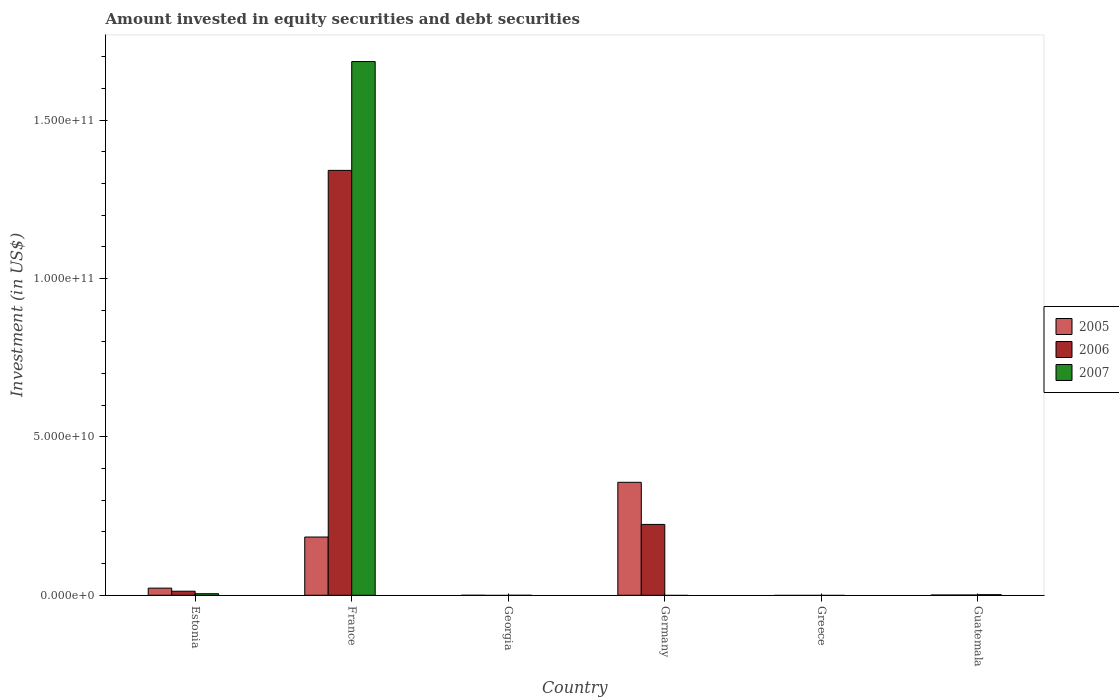How many different coloured bars are there?
Offer a terse response. 3. How many bars are there on the 5th tick from the left?
Provide a succinct answer. 0. What is the label of the 1st group of bars from the left?
Ensure brevity in your answer.  Estonia. What is the amount invested in equity securities and debt securities in 2007 in Estonia?
Give a very brief answer. 4.95e+08. Across all countries, what is the maximum amount invested in equity securities and debt securities in 2006?
Offer a terse response. 1.34e+11. What is the total amount invested in equity securities and debt securities in 2007 in the graph?
Your response must be concise. 1.69e+11. What is the difference between the amount invested in equity securities and debt securities in 2005 in France and that in Germany?
Give a very brief answer. -1.73e+1. What is the difference between the amount invested in equity securities and debt securities in 2007 in Greece and the amount invested in equity securities and debt securities in 2006 in Estonia?
Your response must be concise. -1.28e+09. What is the average amount invested in equity securities and debt securities in 2007 per country?
Give a very brief answer. 2.82e+1. What is the difference between the amount invested in equity securities and debt securities of/in 2006 and amount invested in equity securities and debt securities of/in 2007 in Guatemala?
Offer a very short reply. -1.02e+08. In how many countries, is the amount invested in equity securities and debt securities in 2005 greater than 120000000000 US$?
Make the answer very short. 0. What is the ratio of the amount invested in equity securities and debt securities in 2005 in France to that in Guatemala?
Your answer should be compact. 239.47. Is the amount invested in equity securities and debt securities in 2005 in France less than that in Guatemala?
Keep it short and to the point. No. What is the difference between the highest and the second highest amount invested in equity securities and debt securities in 2005?
Offer a terse response. 3.34e+1. What is the difference between the highest and the lowest amount invested in equity securities and debt securities in 2006?
Your answer should be very brief. 1.34e+11. In how many countries, is the amount invested in equity securities and debt securities in 2006 greater than the average amount invested in equity securities and debt securities in 2006 taken over all countries?
Your answer should be compact. 1. How many bars are there?
Provide a succinct answer. 11. Are all the bars in the graph horizontal?
Offer a terse response. No. How many countries are there in the graph?
Provide a succinct answer. 6. What is the difference between two consecutive major ticks on the Y-axis?
Provide a succinct answer. 5.00e+1. Does the graph contain any zero values?
Provide a short and direct response. Yes. Where does the legend appear in the graph?
Keep it short and to the point. Center right. How are the legend labels stacked?
Ensure brevity in your answer.  Vertical. What is the title of the graph?
Give a very brief answer. Amount invested in equity securities and debt securities. What is the label or title of the X-axis?
Provide a short and direct response. Country. What is the label or title of the Y-axis?
Your response must be concise. Investment (in US$). What is the Investment (in US$) of 2005 in Estonia?
Keep it short and to the point. 2.25e+09. What is the Investment (in US$) of 2006 in Estonia?
Make the answer very short. 1.28e+09. What is the Investment (in US$) in 2007 in Estonia?
Make the answer very short. 4.95e+08. What is the Investment (in US$) of 2005 in France?
Give a very brief answer. 1.84e+1. What is the Investment (in US$) in 2006 in France?
Provide a short and direct response. 1.34e+11. What is the Investment (in US$) of 2007 in France?
Offer a terse response. 1.69e+11. What is the Investment (in US$) of 2005 in Georgia?
Keep it short and to the point. 0. What is the Investment (in US$) of 2006 in Georgia?
Ensure brevity in your answer.  0. What is the Investment (in US$) of 2005 in Germany?
Give a very brief answer. 3.57e+1. What is the Investment (in US$) of 2006 in Germany?
Offer a terse response. 2.24e+1. What is the Investment (in US$) of 2006 in Greece?
Keep it short and to the point. 0. What is the Investment (in US$) in 2007 in Greece?
Your answer should be compact. 0. What is the Investment (in US$) of 2005 in Guatemala?
Your response must be concise. 7.68e+07. What is the Investment (in US$) in 2006 in Guatemala?
Ensure brevity in your answer.  8.34e+07. What is the Investment (in US$) in 2007 in Guatemala?
Your answer should be very brief. 1.85e+08. Across all countries, what is the maximum Investment (in US$) in 2005?
Your answer should be compact. 3.57e+1. Across all countries, what is the maximum Investment (in US$) in 2006?
Provide a short and direct response. 1.34e+11. Across all countries, what is the maximum Investment (in US$) in 2007?
Offer a terse response. 1.69e+11. Across all countries, what is the minimum Investment (in US$) in 2005?
Keep it short and to the point. 0. Across all countries, what is the minimum Investment (in US$) in 2006?
Ensure brevity in your answer.  0. Across all countries, what is the minimum Investment (in US$) of 2007?
Your response must be concise. 0. What is the total Investment (in US$) in 2005 in the graph?
Make the answer very short. 5.64e+1. What is the total Investment (in US$) in 2006 in the graph?
Offer a terse response. 1.58e+11. What is the total Investment (in US$) in 2007 in the graph?
Your answer should be very brief. 1.69e+11. What is the difference between the Investment (in US$) of 2005 in Estonia and that in France?
Ensure brevity in your answer.  -1.61e+1. What is the difference between the Investment (in US$) of 2006 in Estonia and that in France?
Provide a short and direct response. -1.33e+11. What is the difference between the Investment (in US$) in 2007 in Estonia and that in France?
Offer a very short reply. -1.68e+11. What is the difference between the Investment (in US$) of 2005 in Estonia and that in Germany?
Your answer should be very brief. -3.34e+1. What is the difference between the Investment (in US$) of 2006 in Estonia and that in Germany?
Keep it short and to the point. -2.11e+1. What is the difference between the Investment (in US$) of 2005 in Estonia and that in Guatemala?
Your answer should be compact. 2.18e+09. What is the difference between the Investment (in US$) of 2006 in Estonia and that in Guatemala?
Your answer should be very brief. 1.20e+09. What is the difference between the Investment (in US$) of 2007 in Estonia and that in Guatemala?
Your response must be concise. 3.10e+08. What is the difference between the Investment (in US$) of 2005 in France and that in Germany?
Your answer should be compact. -1.73e+1. What is the difference between the Investment (in US$) of 2006 in France and that in Germany?
Keep it short and to the point. 1.12e+11. What is the difference between the Investment (in US$) of 2005 in France and that in Guatemala?
Offer a terse response. 1.83e+1. What is the difference between the Investment (in US$) in 2006 in France and that in Guatemala?
Give a very brief answer. 1.34e+11. What is the difference between the Investment (in US$) in 2007 in France and that in Guatemala?
Keep it short and to the point. 1.68e+11. What is the difference between the Investment (in US$) in 2005 in Germany and that in Guatemala?
Give a very brief answer. 3.56e+1. What is the difference between the Investment (in US$) of 2006 in Germany and that in Guatemala?
Make the answer very short. 2.23e+1. What is the difference between the Investment (in US$) of 2005 in Estonia and the Investment (in US$) of 2006 in France?
Ensure brevity in your answer.  -1.32e+11. What is the difference between the Investment (in US$) of 2005 in Estonia and the Investment (in US$) of 2007 in France?
Offer a very short reply. -1.66e+11. What is the difference between the Investment (in US$) of 2006 in Estonia and the Investment (in US$) of 2007 in France?
Your answer should be compact. -1.67e+11. What is the difference between the Investment (in US$) in 2005 in Estonia and the Investment (in US$) in 2006 in Germany?
Provide a short and direct response. -2.01e+1. What is the difference between the Investment (in US$) in 2005 in Estonia and the Investment (in US$) in 2006 in Guatemala?
Offer a very short reply. 2.17e+09. What is the difference between the Investment (in US$) in 2005 in Estonia and the Investment (in US$) in 2007 in Guatemala?
Your answer should be compact. 2.07e+09. What is the difference between the Investment (in US$) of 2006 in Estonia and the Investment (in US$) of 2007 in Guatemala?
Offer a terse response. 1.10e+09. What is the difference between the Investment (in US$) in 2005 in France and the Investment (in US$) in 2006 in Germany?
Offer a terse response. -3.98e+09. What is the difference between the Investment (in US$) in 2005 in France and the Investment (in US$) in 2006 in Guatemala?
Offer a very short reply. 1.83e+1. What is the difference between the Investment (in US$) of 2005 in France and the Investment (in US$) of 2007 in Guatemala?
Ensure brevity in your answer.  1.82e+1. What is the difference between the Investment (in US$) of 2006 in France and the Investment (in US$) of 2007 in Guatemala?
Keep it short and to the point. 1.34e+11. What is the difference between the Investment (in US$) of 2005 in Germany and the Investment (in US$) of 2006 in Guatemala?
Your answer should be compact. 3.56e+1. What is the difference between the Investment (in US$) in 2005 in Germany and the Investment (in US$) in 2007 in Guatemala?
Provide a short and direct response. 3.55e+1. What is the difference between the Investment (in US$) of 2006 in Germany and the Investment (in US$) of 2007 in Guatemala?
Provide a succinct answer. 2.22e+1. What is the average Investment (in US$) in 2005 per country?
Offer a terse response. 9.40e+09. What is the average Investment (in US$) in 2006 per country?
Give a very brief answer. 2.63e+1. What is the average Investment (in US$) in 2007 per country?
Your answer should be very brief. 2.82e+1. What is the difference between the Investment (in US$) of 2005 and Investment (in US$) of 2006 in Estonia?
Offer a terse response. 9.71e+08. What is the difference between the Investment (in US$) in 2005 and Investment (in US$) in 2007 in Estonia?
Offer a very short reply. 1.76e+09. What is the difference between the Investment (in US$) of 2006 and Investment (in US$) of 2007 in Estonia?
Your answer should be very brief. 7.89e+08. What is the difference between the Investment (in US$) of 2005 and Investment (in US$) of 2006 in France?
Give a very brief answer. -1.16e+11. What is the difference between the Investment (in US$) of 2005 and Investment (in US$) of 2007 in France?
Provide a short and direct response. -1.50e+11. What is the difference between the Investment (in US$) in 2006 and Investment (in US$) in 2007 in France?
Make the answer very short. -3.44e+1. What is the difference between the Investment (in US$) of 2005 and Investment (in US$) of 2006 in Germany?
Offer a very short reply. 1.33e+1. What is the difference between the Investment (in US$) of 2005 and Investment (in US$) of 2006 in Guatemala?
Your answer should be very brief. -6.60e+06. What is the difference between the Investment (in US$) in 2005 and Investment (in US$) in 2007 in Guatemala?
Make the answer very short. -1.08e+08. What is the difference between the Investment (in US$) of 2006 and Investment (in US$) of 2007 in Guatemala?
Give a very brief answer. -1.02e+08. What is the ratio of the Investment (in US$) in 2005 in Estonia to that in France?
Your answer should be very brief. 0.12. What is the ratio of the Investment (in US$) in 2006 in Estonia to that in France?
Ensure brevity in your answer.  0.01. What is the ratio of the Investment (in US$) in 2007 in Estonia to that in France?
Offer a terse response. 0. What is the ratio of the Investment (in US$) of 2005 in Estonia to that in Germany?
Ensure brevity in your answer.  0.06. What is the ratio of the Investment (in US$) of 2006 in Estonia to that in Germany?
Make the answer very short. 0.06. What is the ratio of the Investment (in US$) of 2005 in Estonia to that in Guatemala?
Give a very brief answer. 29.35. What is the ratio of the Investment (in US$) in 2006 in Estonia to that in Guatemala?
Your answer should be very brief. 15.39. What is the ratio of the Investment (in US$) in 2007 in Estonia to that in Guatemala?
Your answer should be very brief. 2.68. What is the ratio of the Investment (in US$) in 2005 in France to that in Germany?
Ensure brevity in your answer.  0.52. What is the ratio of the Investment (in US$) in 2006 in France to that in Germany?
Give a very brief answer. 6. What is the ratio of the Investment (in US$) of 2005 in France to that in Guatemala?
Provide a short and direct response. 239.47. What is the ratio of the Investment (in US$) in 2006 in France to that in Guatemala?
Offer a terse response. 1608.48. What is the ratio of the Investment (in US$) of 2007 in France to that in Guatemala?
Ensure brevity in your answer.  911.33. What is the ratio of the Investment (in US$) in 2005 in Germany to that in Guatemala?
Make the answer very short. 464.44. What is the ratio of the Investment (in US$) in 2006 in Germany to that in Guatemala?
Ensure brevity in your answer.  268.25. What is the difference between the highest and the second highest Investment (in US$) of 2005?
Offer a very short reply. 1.73e+1. What is the difference between the highest and the second highest Investment (in US$) in 2006?
Your answer should be compact. 1.12e+11. What is the difference between the highest and the second highest Investment (in US$) in 2007?
Your response must be concise. 1.68e+11. What is the difference between the highest and the lowest Investment (in US$) in 2005?
Provide a short and direct response. 3.57e+1. What is the difference between the highest and the lowest Investment (in US$) of 2006?
Provide a succinct answer. 1.34e+11. What is the difference between the highest and the lowest Investment (in US$) of 2007?
Offer a terse response. 1.69e+11. 